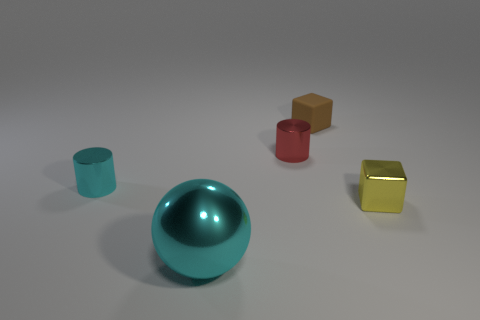What materials do the other objects in the scene appear to be made of? Aside from the metallic objects, the image contains a cylinder and a cube that both appear to have matte surfaces—likely a type of plastic or painted wood due to the lack of reflection and the uniformity of the surface texture. 